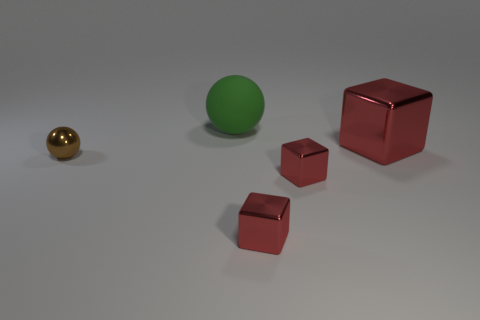Subtract all big red cubes. How many cubes are left? 2 Add 4 tiny spheres. How many objects exist? 9 Subtract all balls. How many objects are left? 3 Subtract all cyan metallic spheres. Subtract all large rubber spheres. How many objects are left? 4 Add 4 green matte balls. How many green matte balls are left? 5 Add 2 red blocks. How many red blocks exist? 5 Subtract 0 blue balls. How many objects are left? 5 Subtract all gray cubes. Subtract all green cylinders. How many cubes are left? 3 